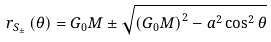Convert formula to latex. <formula><loc_0><loc_0><loc_500><loc_500>r _ { S _ { \pm } } \left ( \theta \right ) = G _ { 0 } M \pm \sqrt { \left ( G _ { 0 } M \right ) ^ { 2 } - a ^ { 2 } \cos ^ { 2 } \theta }</formula> 